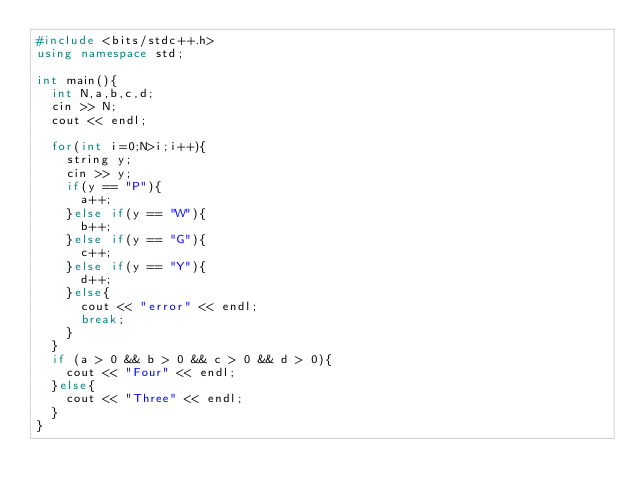<code> <loc_0><loc_0><loc_500><loc_500><_C++_>#include <bits/stdc++.h>
using namespace std;

int main(){
  int N,a,b,c,d;
  cin >> N;
  cout << endl;
  
  for(int i=0;N>i;i++){
    string y;
    cin >> y;
    if(y == "P"){
      a++;
    }else if(y == "W"){
      b++;
    }else if(y == "G"){
      c++;
    }else if(y == "Y"){
      d++;
    }else{
      cout << "error" << endl;
      break;
    }
  }
  if (a > 0 && b > 0 && c > 0 && d > 0){
    cout << "Four" << endl;
  }else{
    cout << "Three" << endl;
  }
}
    
</code> 